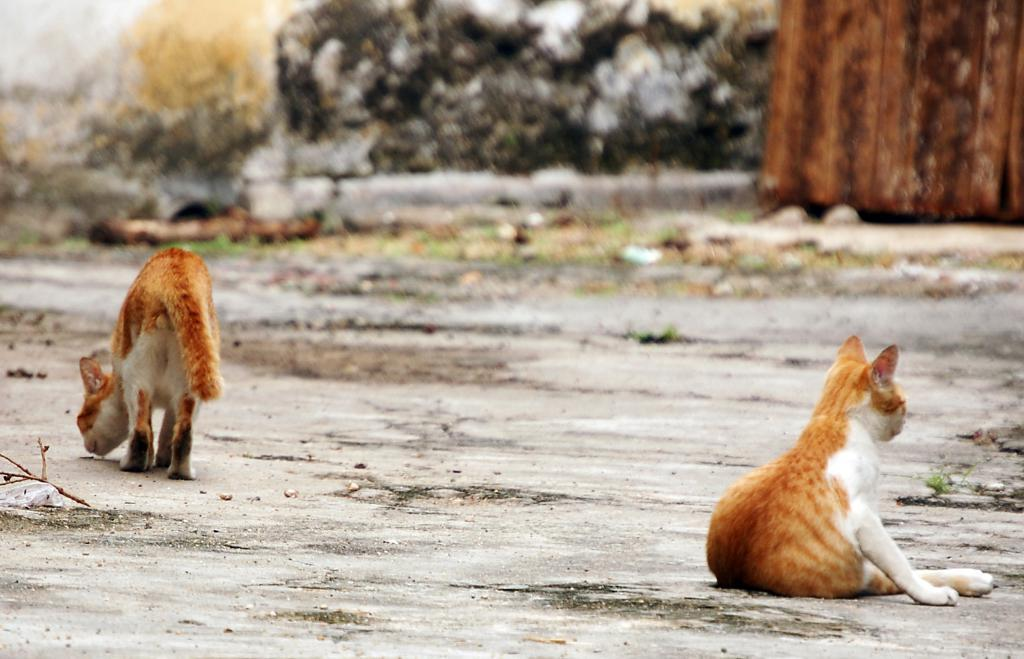What animals are present on the ground in the image? There are cats on the ground in the image. What can be seen in the background of the image? There is a wall visible in the background of the image. What type of calendar is hanging on the wall in the image? There is no calendar present in the image; it only features cats on the ground and a wall in the background. 